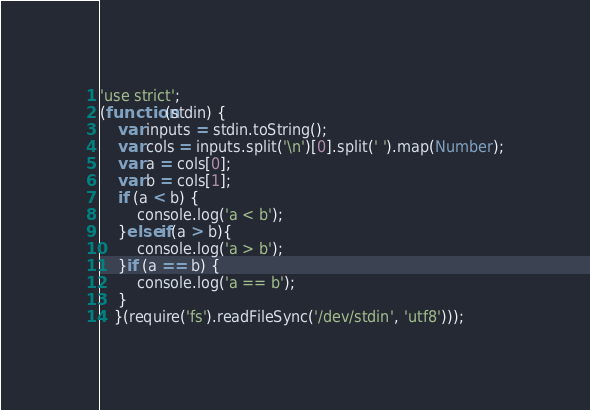Convert code to text. <code><loc_0><loc_0><loc_500><loc_500><_JavaScript_>'use strict';
(function(stdin) {
    var inputs = stdin.toString();
    var cols = inputs.split('\n')[0].split(' ').map(Number);
    var a = cols[0];
    var b = cols[1];
    if (a < b) {
        console.log('a < b');
    }else if(a > b){
        console.log('a > b');
    }if (a == b) {
        console.log('a == b');
    }
   }(require('fs').readFileSync('/dev/stdin', 'utf8')));</code> 